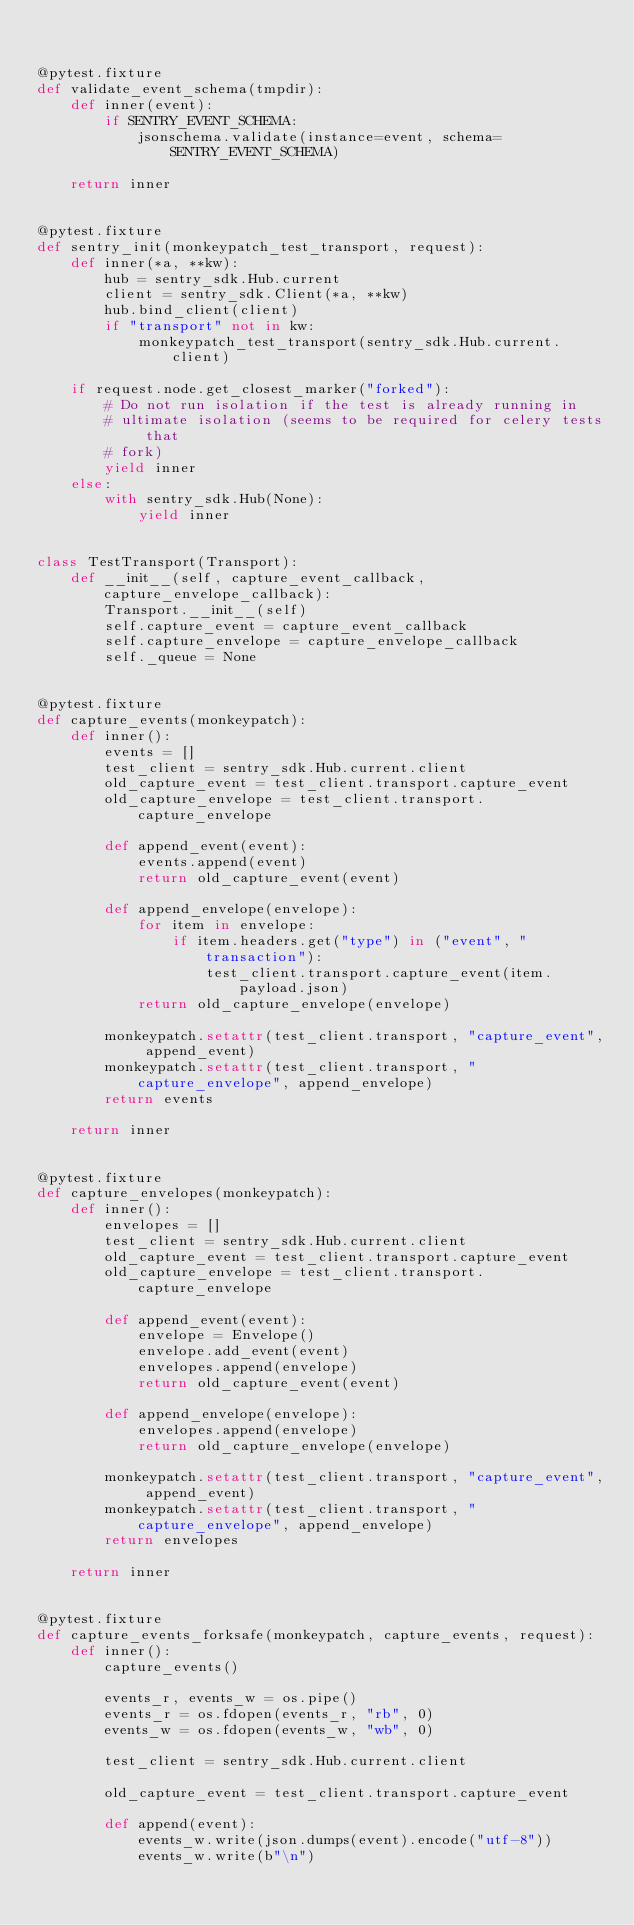<code> <loc_0><loc_0><loc_500><loc_500><_Python_>

@pytest.fixture
def validate_event_schema(tmpdir):
    def inner(event):
        if SENTRY_EVENT_SCHEMA:
            jsonschema.validate(instance=event, schema=SENTRY_EVENT_SCHEMA)

    return inner


@pytest.fixture
def sentry_init(monkeypatch_test_transport, request):
    def inner(*a, **kw):
        hub = sentry_sdk.Hub.current
        client = sentry_sdk.Client(*a, **kw)
        hub.bind_client(client)
        if "transport" not in kw:
            monkeypatch_test_transport(sentry_sdk.Hub.current.client)

    if request.node.get_closest_marker("forked"):
        # Do not run isolation if the test is already running in
        # ultimate isolation (seems to be required for celery tests that
        # fork)
        yield inner
    else:
        with sentry_sdk.Hub(None):
            yield inner


class TestTransport(Transport):
    def __init__(self, capture_event_callback, capture_envelope_callback):
        Transport.__init__(self)
        self.capture_event = capture_event_callback
        self.capture_envelope = capture_envelope_callback
        self._queue = None


@pytest.fixture
def capture_events(monkeypatch):
    def inner():
        events = []
        test_client = sentry_sdk.Hub.current.client
        old_capture_event = test_client.transport.capture_event
        old_capture_envelope = test_client.transport.capture_envelope

        def append_event(event):
            events.append(event)
            return old_capture_event(event)

        def append_envelope(envelope):
            for item in envelope:
                if item.headers.get("type") in ("event", "transaction"):
                    test_client.transport.capture_event(item.payload.json)
            return old_capture_envelope(envelope)

        monkeypatch.setattr(test_client.transport, "capture_event", append_event)
        monkeypatch.setattr(test_client.transport, "capture_envelope", append_envelope)
        return events

    return inner


@pytest.fixture
def capture_envelopes(monkeypatch):
    def inner():
        envelopes = []
        test_client = sentry_sdk.Hub.current.client
        old_capture_event = test_client.transport.capture_event
        old_capture_envelope = test_client.transport.capture_envelope

        def append_event(event):
            envelope = Envelope()
            envelope.add_event(event)
            envelopes.append(envelope)
            return old_capture_event(event)

        def append_envelope(envelope):
            envelopes.append(envelope)
            return old_capture_envelope(envelope)

        monkeypatch.setattr(test_client.transport, "capture_event", append_event)
        monkeypatch.setattr(test_client.transport, "capture_envelope", append_envelope)
        return envelopes

    return inner


@pytest.fixture
def capture_events_forksafe(monkeypatch, capture_events, request):
    def inner():
        capture_events()

        events_r, events_w = os.pipe()
        events_r = os.fdopen(events_r, "rb", 0)
        events_w = os.fdopen(events_w, "wb", 0)

        test_client = sentry_sdk.Hub.current.client

        old_capture_event = test_client.transport.capture_event

        def append(event):
            events_w.write(json.dumps(event).encode("utf-8"))
            events_w.write(b"\n")</code> 